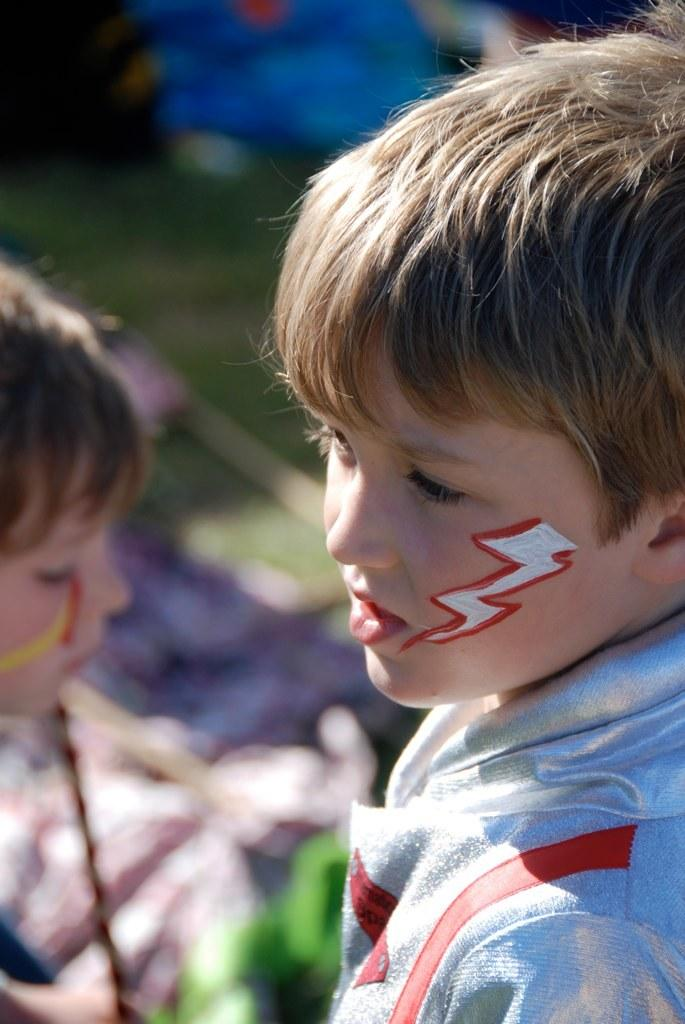What is the main subject in the foreground of the image? There is a boy in the foreground of the image. Can you describe the background of the image? There is another boy in the background of the image. What else can be seen in the image besides the boys? There are some objects visible in the image. What type of natural environment is present in the image? Grass is present in the image. What type of account does the boy in the foreground have in the image? There is no mention of an account in the image, as it features two boys and some objects in a grassy environment. 